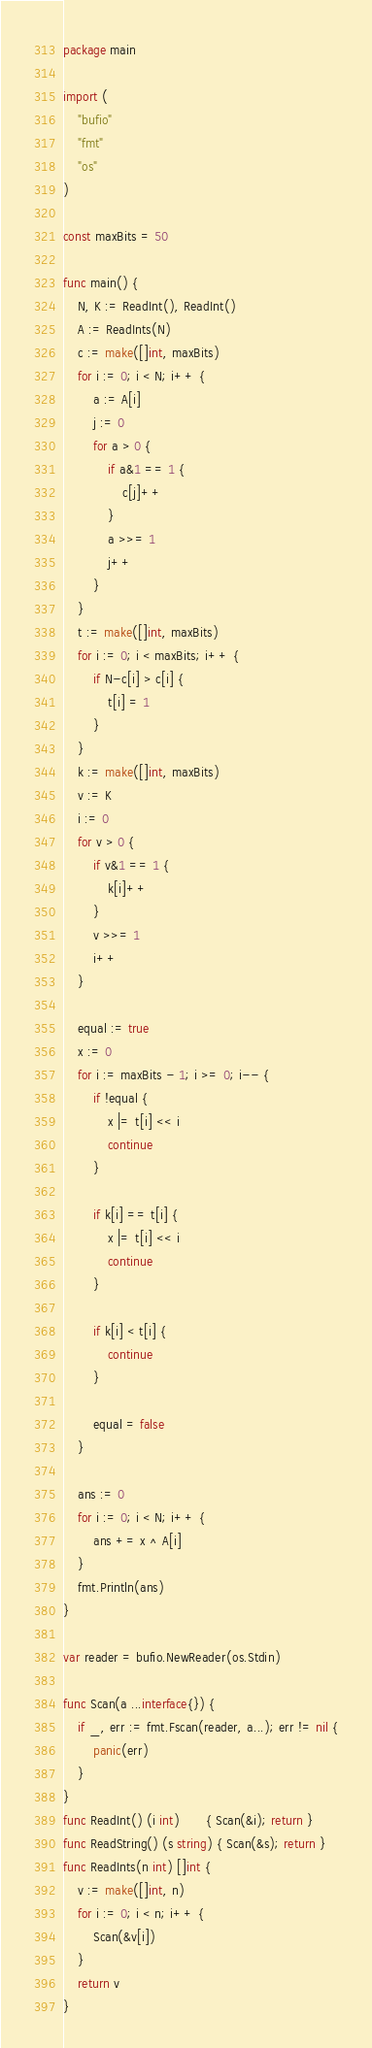<code> <loc_0><loc_0><loc_500><loc_500><_Go_>package main

import (
	"bufio"
	"fmt"
	"os"
)

const maxBits = 50

func main() {
	N, K := ReadInt(), ReadInt()
	A := ReadInts(N)
	c := make([]int, maxBits)
	for i := 0; i < N; i++ {
		a := A[i]
		j := 0
		for a > 0 {
			if a&1 == 1 {
				c[j]++
			}
			a >>= 1
			j++
		}
	}
	t := make([]int, maxBits)
	for i := 0; i < maxBits; i++ {
		if N-c[i] > c[i] {
			t[i] = 1
		}
	}
	k := make([]int, maxBits)
	v := K
	i := 0
	for v > 0 {
		if v&1 == 1 {
			k[i]++
		}
		v >>= 1
		i++
	}

	equal := true
	x := 0
	for i := maxBits - 1; i >= 0; i-- {
		if !equal {
			x |= t[i] << i
			continue
		}

		if k[i] == t[i] {
			x |= t[i] << i
			continue
		}

		if k[i] < t[i] {
			continue
		}

		equal = false
	}

	ans := 0
	for i := 0; i < N; i++ {
		ans += x ^ A[i]
	}
	fmt.Println(ans)
}

var reader = bufio.NewReader(os.Stdin)

func Scan(a ...interface{}) {
	if _, err := fmt.Fscan(reader, a...); err != nil {
		panic(err)
	}
}
func ReadInt() (i int)       { Scan(&i); return }
func ReadString() (s string) { Scan(&s); return }
func ReadInts(n int) []int {
	v := make([]int, n)
	for i := 0; i < n; i++ {
		Scan(&v[i])
	}
	return v
}
</code> 